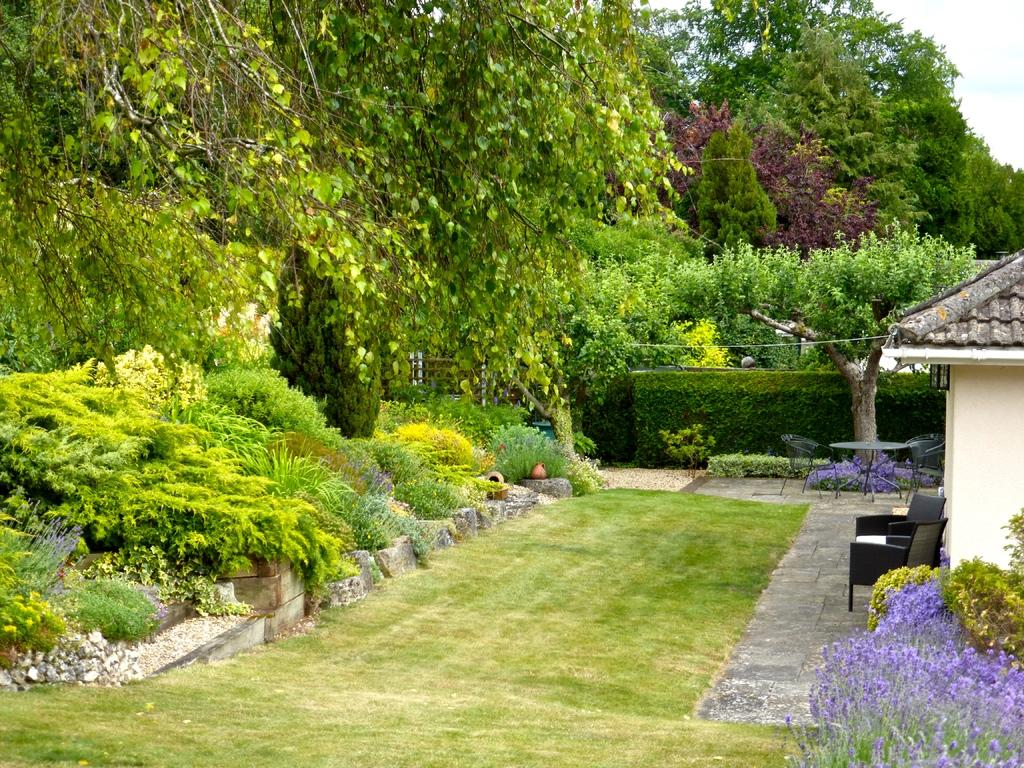What type of vegetation can be seen in the image? There is grass, plants, flowers, and trees in the image. What type of furniture is present in the image? There are chairs in the image. What type of structure is visible in the image? There is a house in the image. What is visible in the background of the image? The sky is visible in the background of the image. What is the grandmother's fear in the image? There is no grandmother or fear present in the image. What is the best way to reach the house in the image? The image does not provide information about the location or accessibility of the house, so it is not possible to determine the best way to reach it. 